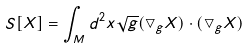<formula> <loc_0><loc_0><loc_500><loc_500>S [ X ] = \int _ { M } d ^ { 2 } x \sqrt { g } ( \bigtriangledown _ { g } X ) \cdot ( \bigtriangledown _ { g } X )</formula> 